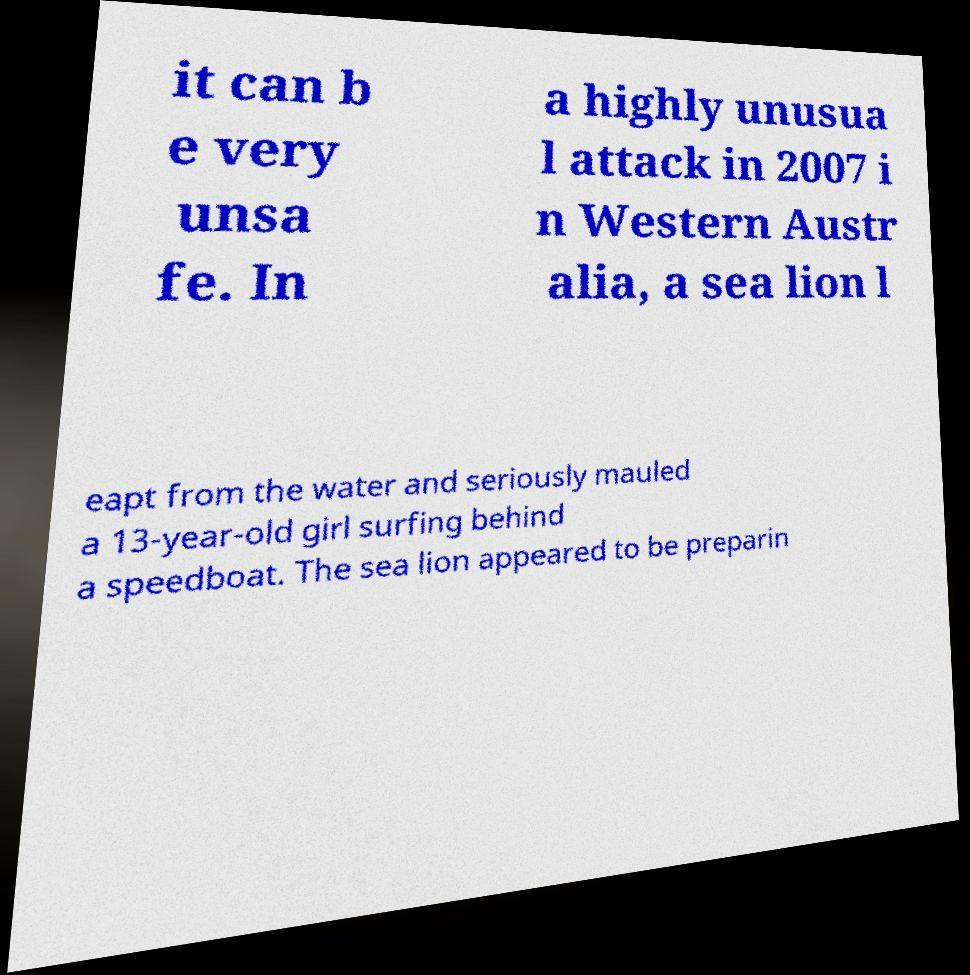Could you assist in decoding the text presented in this image and type it out clearly? it can b e very unsa fe. In a highly unusua l attack in 2007 i n Western Austr alia, a sea lion l eapt from the water and seriously mauled a 13-year-old girl surfing behind a speedboat. The sea lion appeared to be preparin 